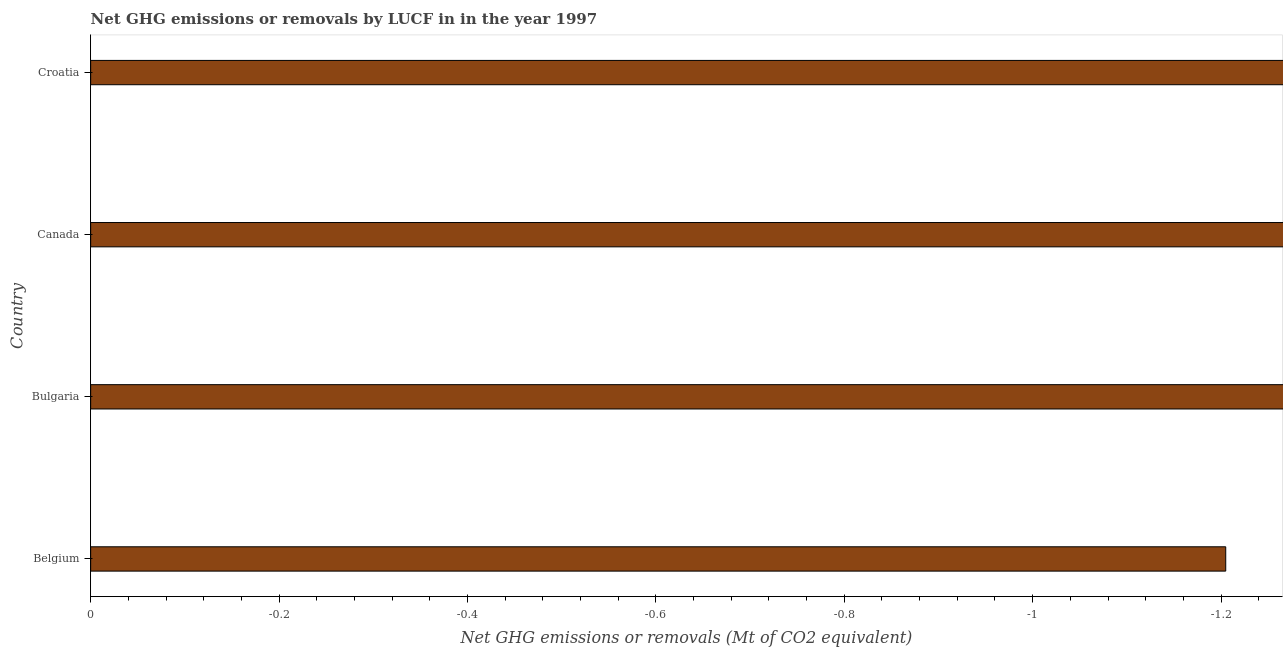Does the graph contain any zero values?
Your answer should be very brief. Yes. Does the graph contain grids?
Provide a succinct answer. No. What is the title of the graph?
Offer a terse response. Net GHG emissions or removals by LUCF in in the year 1997. What is the label or title of the X-axis?
Provide a succinct answer. Net GHG emissions or removals (Mt of CO2 equivalent). What is the label or title of the Y-axis?
Offer a terse response. Country. What is the average ghg net emissions or removals per country?
Your answer should be very brief. 0. What is the median ghg net emissions or removals?
Your answer should be compact. 0. In how many countries, is the ghg net emissions or removals greater than -0.88 Mt?
Your response must be concise. 0. In how many countries, is the ghg net emissions or removals greater than the average ghg net emissions or removals taken over all countries?
Your answer should be compact. 0. Are all the bars in the graph horizontal?
Ensure brevity in your answer.  Yes. How many countries are there in the graph?
Offer a terse response. 4. What is the difference between two consecutive major ticks on the X-axis?
Provide a short and direct response. 0.2. What is the Net GHG emissions or removals (Mt of CO2 equivalent) in Belgium?
Provide a succinct answer. 0. What is the Net GHG emissions or removals (Mt of CO2 equivalent) of Bulgaria?
Keep it short and to the point. 0. What is the Net GHG emissions or removals (Mt of CO2 equivalent) of Canada?
Offer a very short reply. 0. What is the Net GHG emissions or removals (Mt of CO2 equivalent) in Croatia?
Ensure brevity in your answer.  0. 